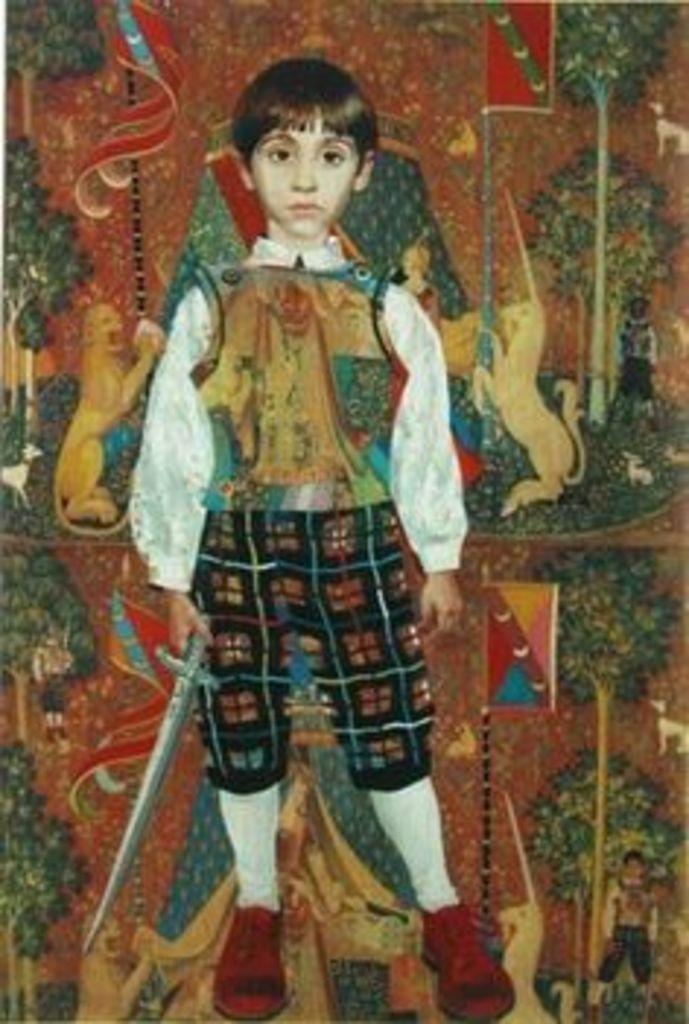In one or two sentences, can you explain what this image depicts? In this image we can see a painting of a boy holding a sword, and behind him there are paintings of some animals trees and flag. 